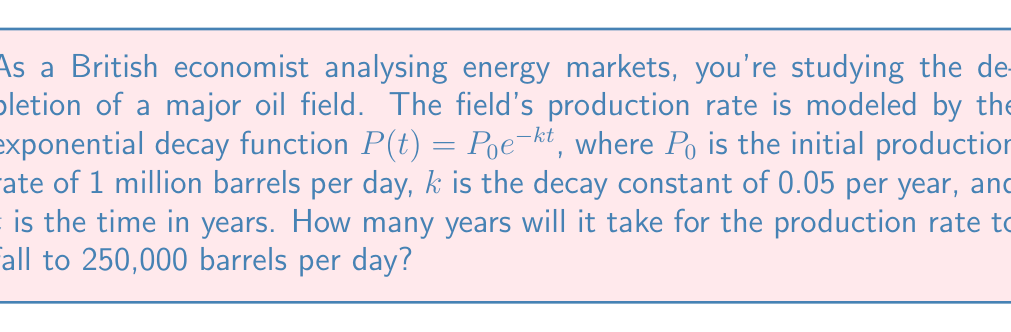What is the answer to this math problem? To solve this problem, we'll use the logarithmic properties of the exponential decay function:

1) We start with the given equation: $P(t) = P_0 e^{-kt}$

2) We know:
   $P_0 = 1,000,000$ barrels/day
   $k = 0.05$ per year
   $P(t) = 250,000$ barrels/day (the target production rate)

3) Substitute these values into the equation:
   $250,000 = 1,000,000 e^{-0.05t}$

4) Divide both sides by 1,000,000:
   $\frac{250,000}{1,000,000} = e^{-0.05t}$
   $0.25 = e^{-0.05t}$

5) Take the natural logarithm of both sides:
   $\ln(0.25) = \ln(e^{-0.05t})$

6) Simplify the right side using the logarithm property $\ln(e^x) = x$:
   $\ln(0.25) = -0.05t$

7) Solve for $t$:
   $t = \frac{\ln(0.25)}{-0.05}$

8) Calculate the result:
   $t = \frac{-1.386294361}{-0.05} \approx 27.73$ years

Therefore, it will take approximately 27.73 years for the production rate to fall to 250,000 barrels per day.
Answer: 27.73 years 